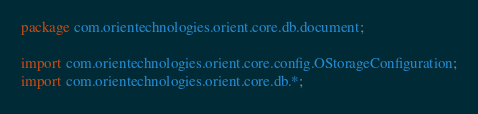<code> <loc_0><loc_0><loc_500><loc_500><_Java_>package com.orientechnologies.orient.core.db.document;

import com.orientechnologies.orient.core.config.OStorageConfiguration;
import com.orientechnologies.orient.core.db.*;</code> 